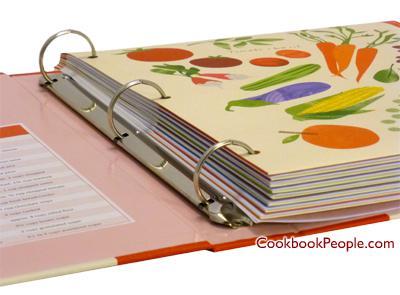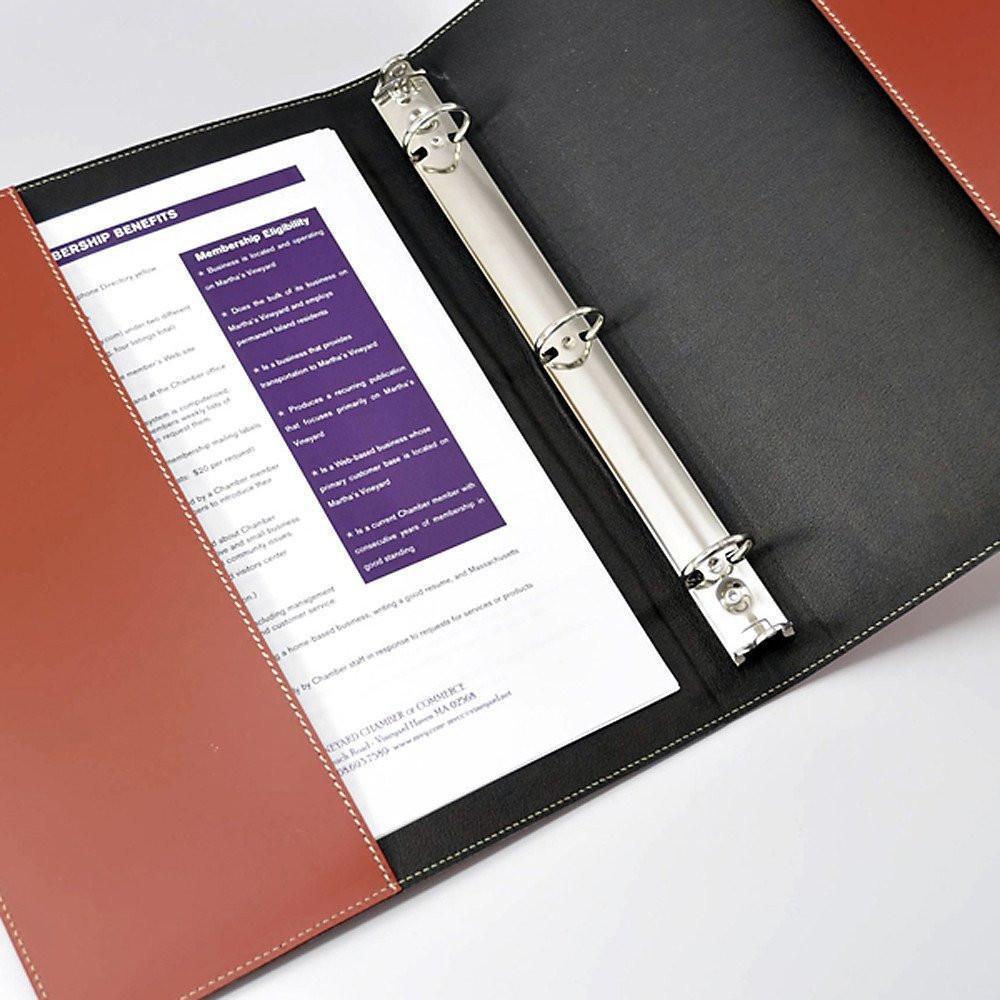The first image is the image on the left, the second image is the image on the right. Given the left and right images, does the statement "One of the binders is white and closed." hold true? Answer yes or no. No. 